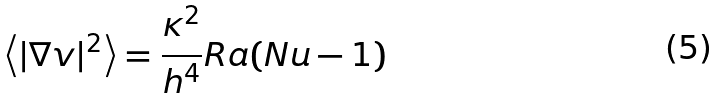<formula> <loc_0><loc_0><loc_500><loc_500>\left < | \nabla v | ^ { 2 } \right > = \frac { \kappa ^ { 2 } } { h ^ { 4 } } R a ( N u - 1 )</formula> 